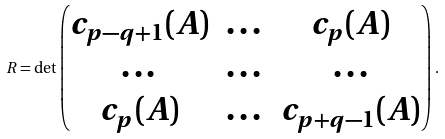<formula> <loc_0><loc_0><loc_500><loc_500>R = \det \begin{pmatrix} c _ { p - q + 1 } ( A ) & \dots & c _ { p } ( A ) \\ \dots & \dots & \dots \\ c _ { p } ( A ) & \dots & c _ { p + q - 1 } ( A ) \\ \end{pmatrix} \, .</formula> 